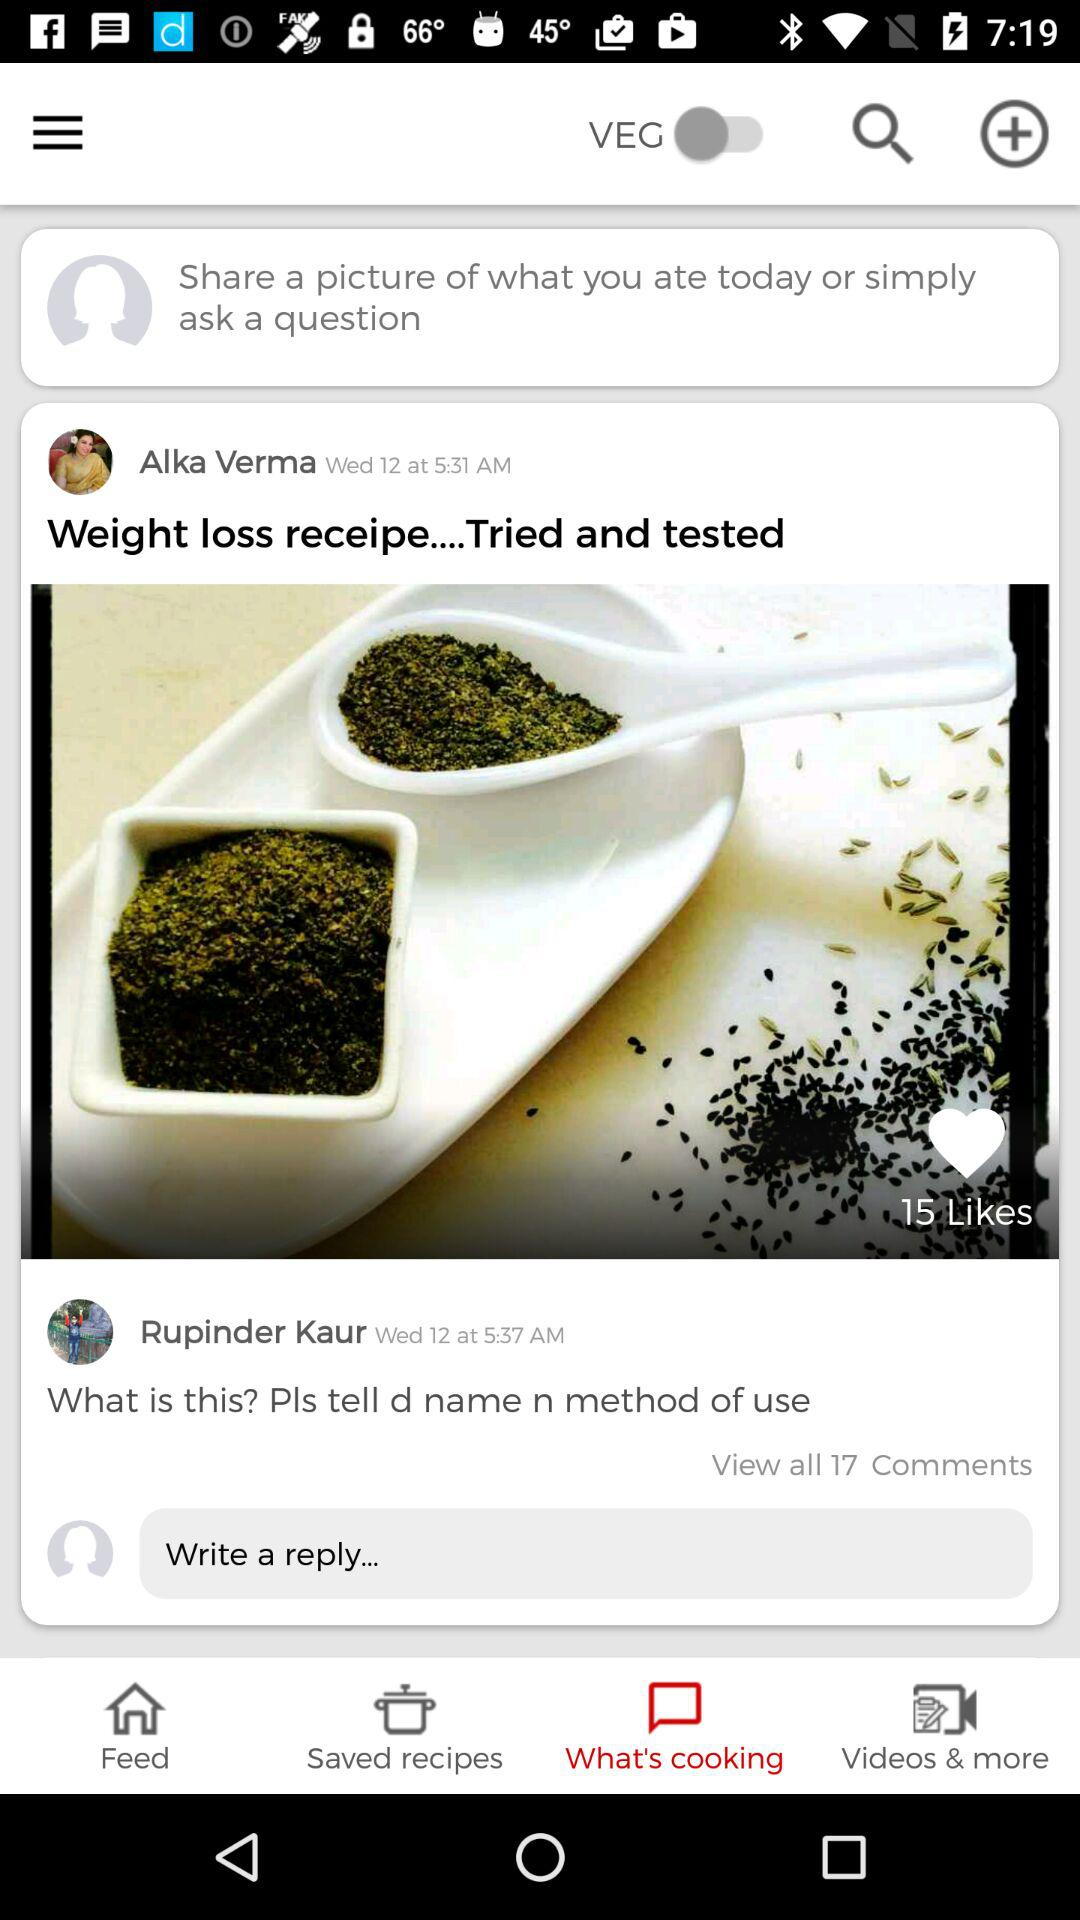What is the status of the Veg? The status of the Veg is off. 